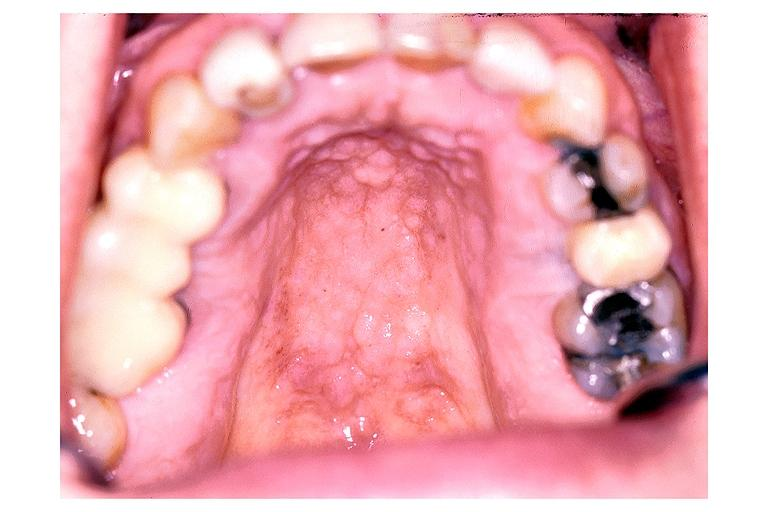does this image show inflamatory papillary hyperplasia?
Answer the question using a single word or phrase. Yes 